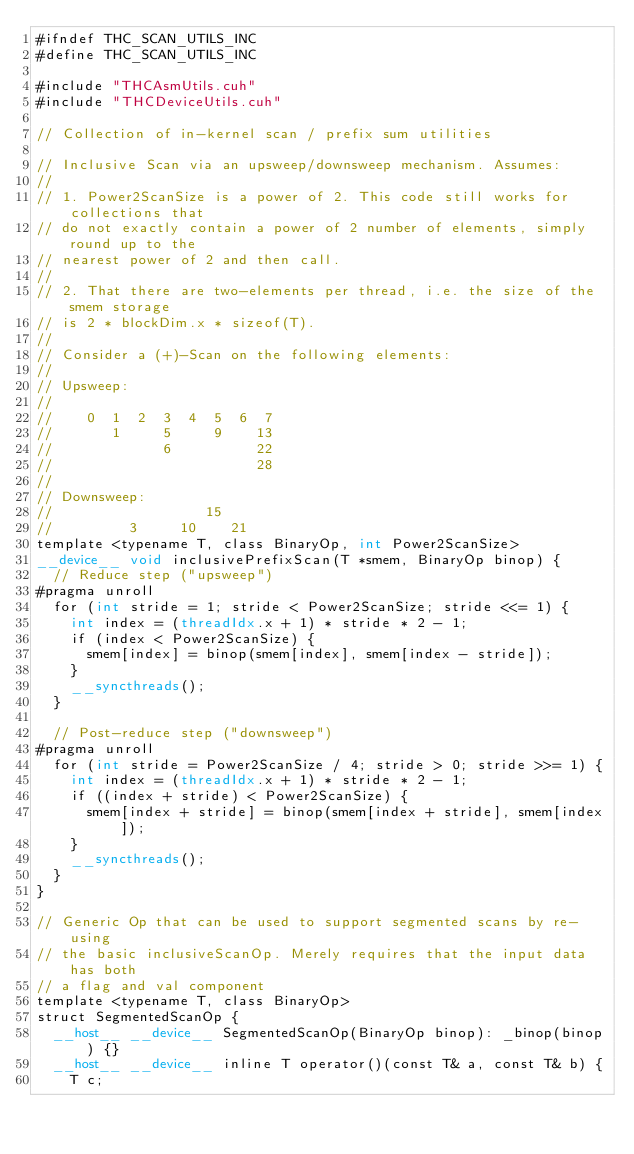Convert code to text. <code><loc_0><loc_0><loc_500><loc_500><_Cuda_>#ifndef THC_SCAN_UTILS_INC
#define THC_SCAN_UTILS_INC

#include "THCAsmUtils.cuh"
#include "THCDeviceUtils.cuh"

// Collection of in-kernel scan / prefix sum utilities

// Inclusive Scan via an upsweep/downsweep mechanism. Assumes:
//
// 1. Power2ScanSize is a power of 2. This code still works for collections that
// do not exactly contain a power of 2 number of elements, simply round up to the
// nearest power of 2 and then call.
//
// 2. That there are two-elements per thread, i.e. the size of the smem storage
// is 2 * blockDim.x * sizeof(T).
//
// Consider a (+)-Scan on the following elements:
//
// Upsweep:
//
//    0  1  2  3  4  5  6  7
//       1     5     9    13
//             6          22
//                        28
//
// Downsweep:
//                  15
//         3     10    21
template <typename T, class BinaryOp, int Power2ScanSize>
__device__ void inclusivePrefixScan(T *smem, BinaryOp binop) {
  // Reduce step ("upsweep")
#pragma unroll
  for (int stride = 1; stride < Power2ScanSize; stride <<= 1) {
    int index = (threadIdx.x + 1) * stride * 2 - 1;
    if (index < Power2ScanSize) {
      smem[index] = binop(smem[index], smem[index - stride]);
    }
    __syncthreads();
  }

  // Post-reduce step ("downsweep")
#pragma unroll
  for (int stride = Power2ScanSize / 4; stride > 0; stride >>= 1) {
    int index = (threadIdx.x + 1) * stride * 2 - 1;
    if ((index + stride) < Power2ScanSize) {
      smem[index + stride] = binop(smem[index + stride], smem[index]);
    }
    __syncthreads();
  }
}

// Generic Op that can be used to support segmented scans by re-using
// the basic inclusiveScanOp. Merely requires that the input data has both
// a flag and val component
template <typename T, class BinaryOp>
struct SegmentedScanOp {
  __host__ __device__ SegmentedScanOp(BinaryOp binop): _binop(binop) {}
  __host__ __device__ inline T operator()(const T& a, const T& b) {
    T c;</code> 